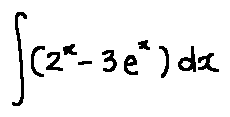Convert formula to latex. <formula><loc_0><loc_0><loc_500><loc_500>\int ( 2 ^ { x } - 3 e ^ { x } ) d x</formula> 